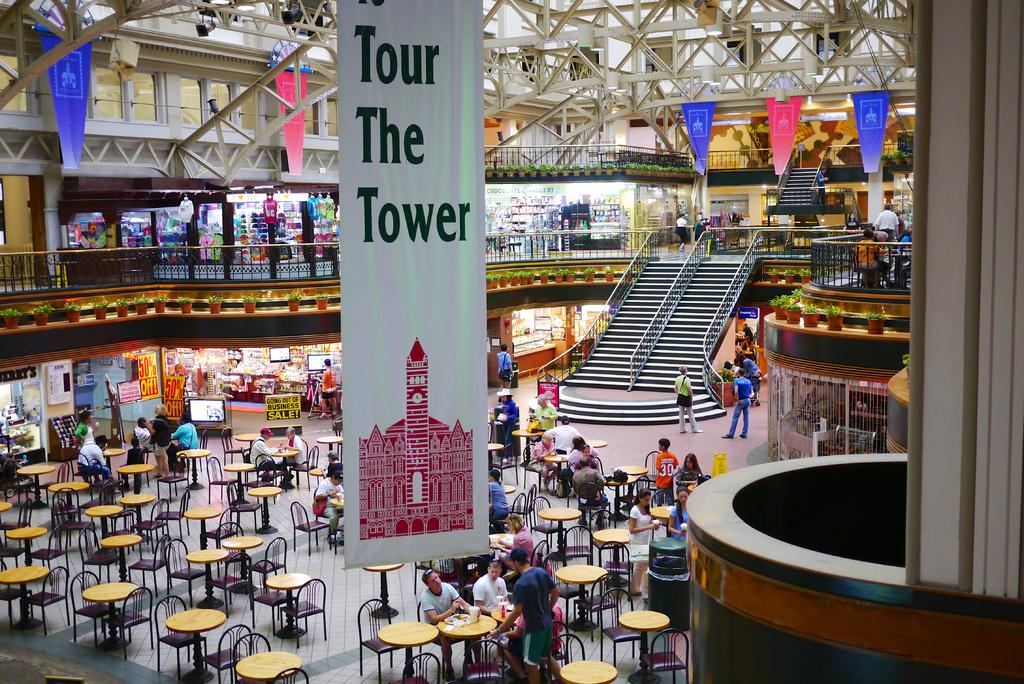<image>
Render a clear and concise summary of the photo. A mostly empty indoor building displaying the sign Tour The Tower hanging on a banner. 